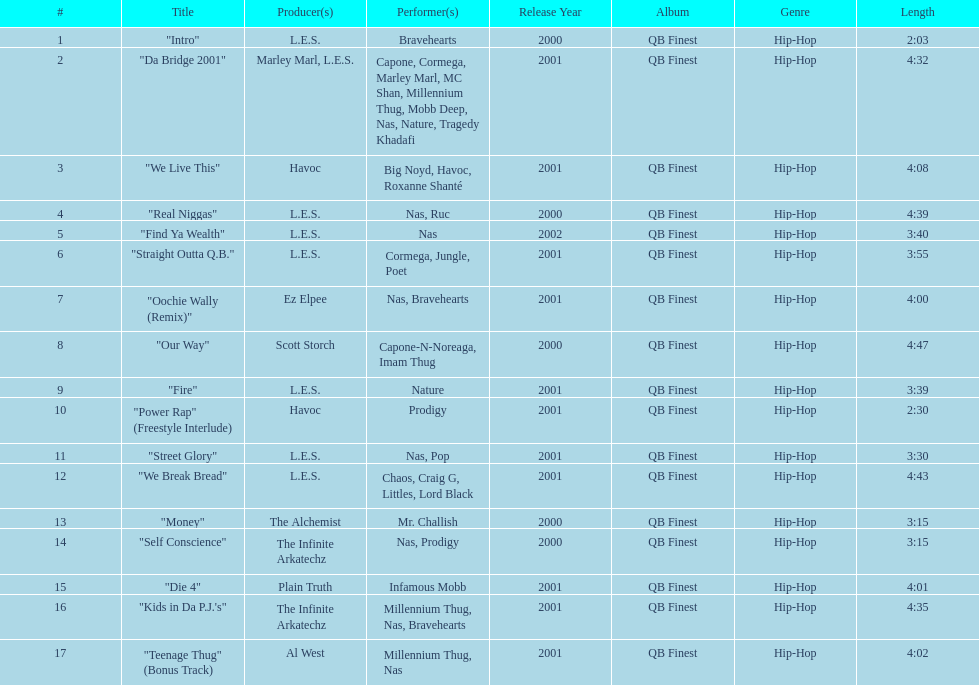What song was performed before "fire"? "Our Way". 